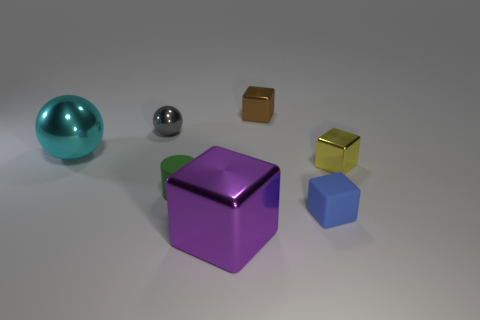Subtract all matte cubes. How many cubes are left? 3 Subtract 3 blocks. How many blocks are left? 1 Subtract all purple blocks. How many blocks are left? 3 Add 1 tiny yellow metallic blocks. How many objects exist? 8 Subtract all cylinders. How many objects are left? 6 Subtract all gray cylinders. Subtract all cyan blocks. How many cylinders are left? 1 Subtract all red balls. How many purple cylinders are left? 0 Subtract all large metallic spheres. Subtract all small brown metal objects. How many objects are left? 5 Add 5 blue objects. How many blue objects are left? 6 Add 3 tiny yellow blocks. How many tiny yellow blocks exist? 4 